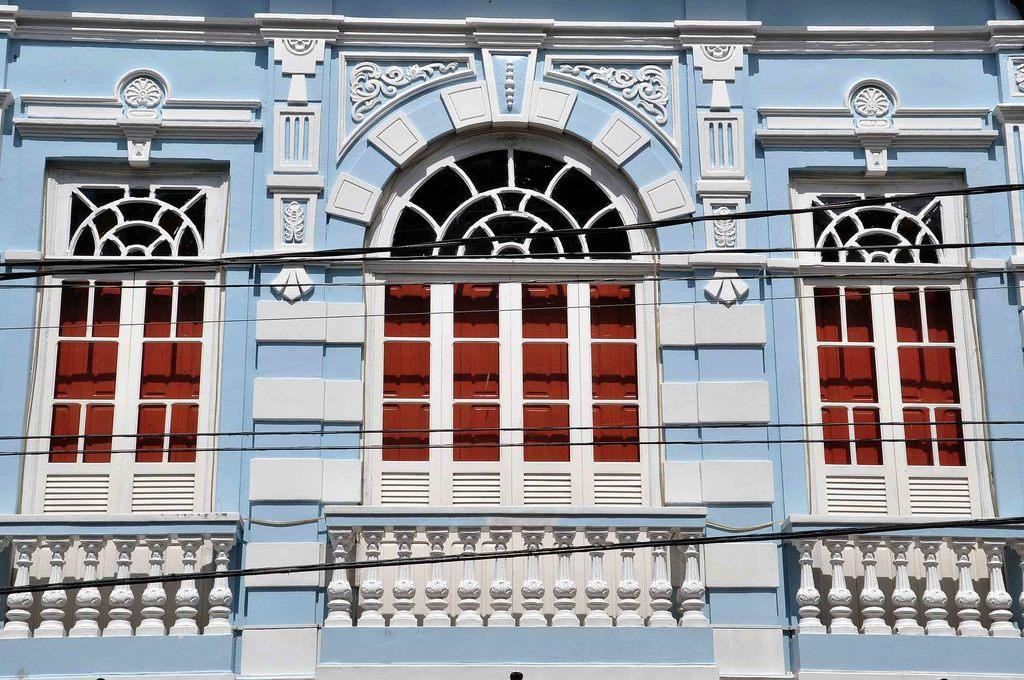Describe this image in one or two sentences. In this image I can see the building, windows, railing and few wires. 